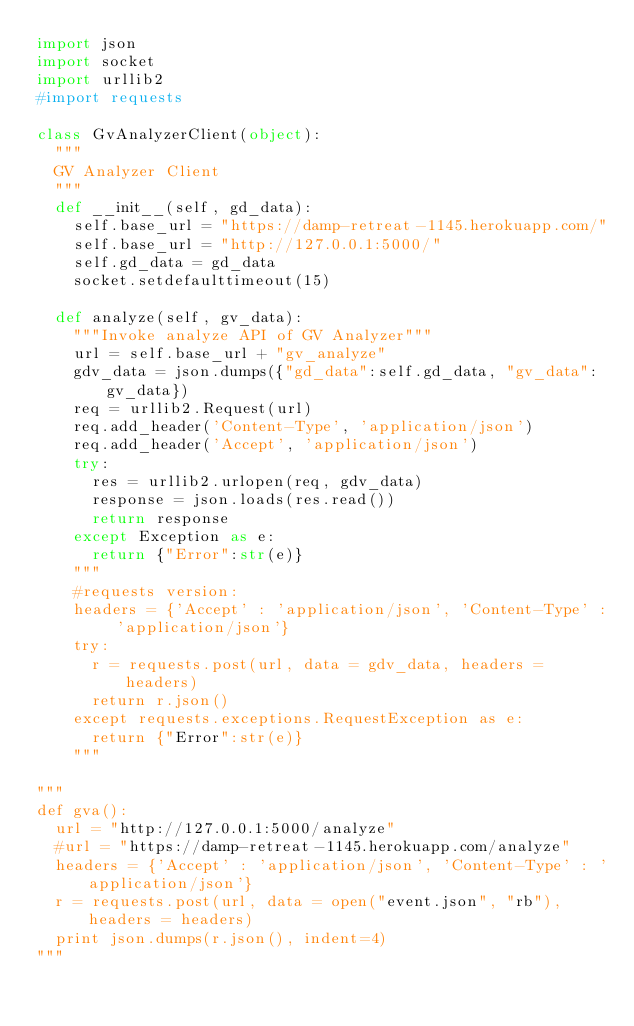Convert code to text. <code><loc_0><loc_0><loc_500><loc_500><_Python_>import json
import socket
import urllib2
#import requests

class GvAnalyzerClient(object):
	"""
	GV Analyzer Client
	"""
	def __init__(self, gd_data):
		self.base_url = "https://damp-retreat-1145.herokuapp.com/"
		self.base_url = "http://127.0.0.1:5000/"
		self.gd_data = gd_data
		socket.setdefaulttimeout(15)

	def analyze(self, gv_data):
		"""Invoke analyze API of GV Analyzer"""
		url = self.base_url + "gv_analyze"
		gdv_data = json.dumps({"gd_data":self.gd_data, "gv_data":gv_data})
		req = urllib2.Request(url)
		req.add_header('Content-Type', 'application/json')
		req.add_header('Accept', 'application/json')
		try:
			res = urllib2.urlopen(req, gdv_data)
			response = json.loads(res.read())
			return response
		except Exception as e:
			return {"Error":str(e)}
		"""
		#requests version:
		headers = {'Accept' : 'application/json', 'Content-Type' : 'application/json'}
		try:
			r = requests.post(url, data = gdv_data, headers = headers)
			return r.json()
		except requests.exceptions.RequestException as e:
			return {"Error":str(e)}
		"""

"""
def gva():
	url = "http://127.0.0.1:5000/analyze"
	#url = "https://damp-retreat-1145.herokuapp.com/analyze"
	headers = {'Accept' : 'application/json', 'Content-Type' : 'application/json'}
	r = requests.post(url, data = open("event.json", "rb"), headers = headers)
	print json.dumps(r.json(), indent=4)
"""</code> 